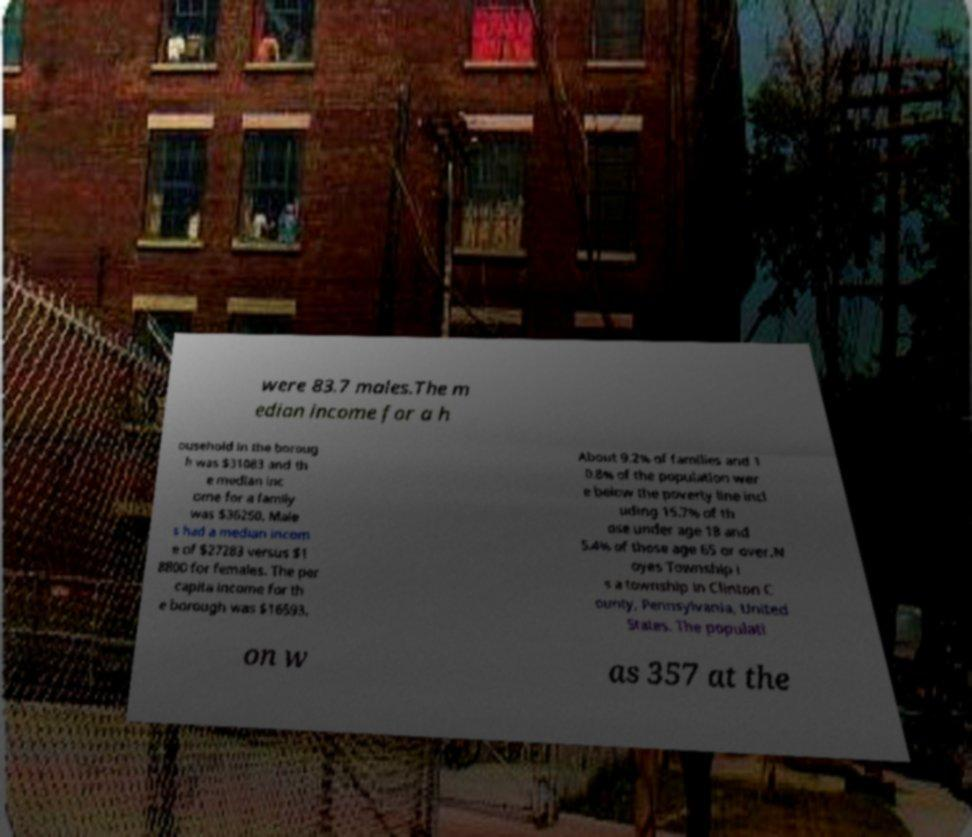There's text embedded in this image that I need extracted. Can you transcribe it verbatim? were 83.7 males.The m edian income for a h ousehold in the boroug h was $31083 and th e median inc ome for a family was $36250. Male s had a median incom e of $27283 versus $1 8800 for females. The per capita income for th e borough was $16593. About 9.2% of families and 1 0.8% of the population wer e below the poverty line incl uding 15.7% of th ose under age 18 and 5.4% of those age 65 or over.N oyes Township i s a township in Clinton C ounty, Pennsylvania, United States. The populati on w as 357 at the 